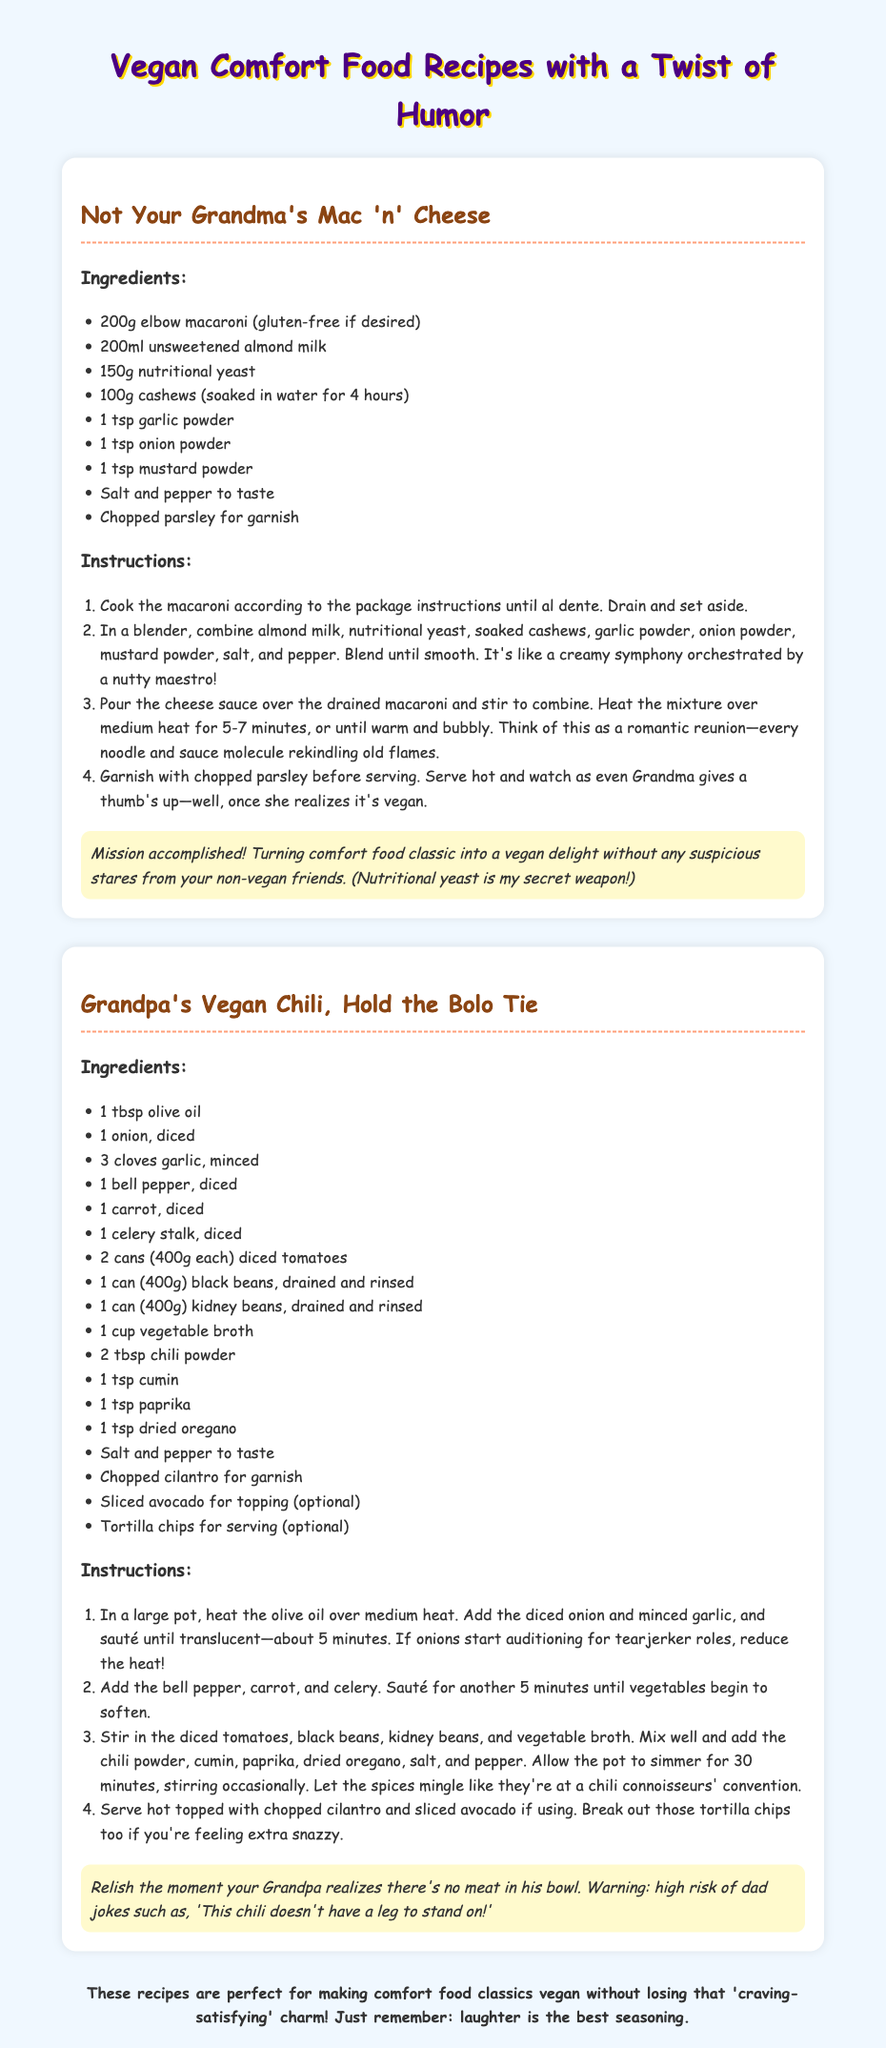What is the title of the first recipe? The title of the first recipe is "Not Your Grandma's Mac 'n' Cheese."
Answer: Not Your Grandma's Mac 'n' Cheese How many tablespoons of chili powder are needed? The quantity of chili powder required in the Grandpa's Vegan Chili recipe is stated in the ingredients list, which says 2 tablespoons.
Answer: 2 tablespoons What ingredient is suggested for garnish in the mac 'n' cheese? The garnish suggested for the mac 'n' cheese dish is chopped parsley, as mentioned in the instructions.
Answer: Chopped parsley How long should the chili simmer? The instructions specify that the chili should simmer for 30 minutes.
Answer: 30 minutes What type of milk is used in the mac 'n' cheese? The ingredient list for the mac 'n' cheese indicates that unsweetened almond milk is used.
Answer: Unsweetened almond milk What should you do if the onions start crying? The recipe humorously suggests to reduce the heat if the onions start auditioning for tearjerker roles.
Answer: Reduce the heat What is the humorous warning associated with the chili recipe? The humorous note mentions a warning about the risk of dad jokes when Grandpa realizes there is no meat in the chili.
Answer: High risk of dad jokes Which recipe uses cashews? The recipe titled "Not Your Grandma's Mac 'n' Cheese" includes cashews as an ingredient.
Answer: Not Your Grandma's Mac 'n' Cheese What spices are included in the chili recipe? The chili recipe requires chili powder, cumin, paprika, and dried oregano, according to the ingredient list.
Answer: Chili powder, cumin, paprika, dried oregano 